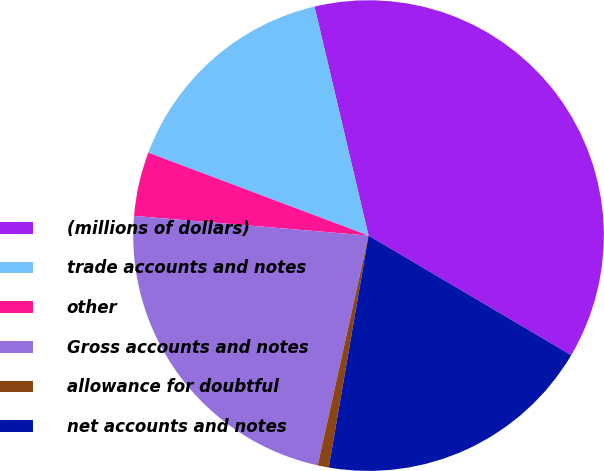Convert chart to OTSL. <chart><loc_0><loc_0><loc_500><loc_500><pie_chart><fcel>(millions of dollars)<fcel>trade accounts and notes<fcel>other<fcel>Gross accounts and notes<fcel>allowance for doubtful<fcel>net accounts and notes<nl><fcel>37.17%<fcel>15.58%<fcel>4.4%<fcel>22.87%<fcel>0.76%<fcel>19.22%<nl></chart> 